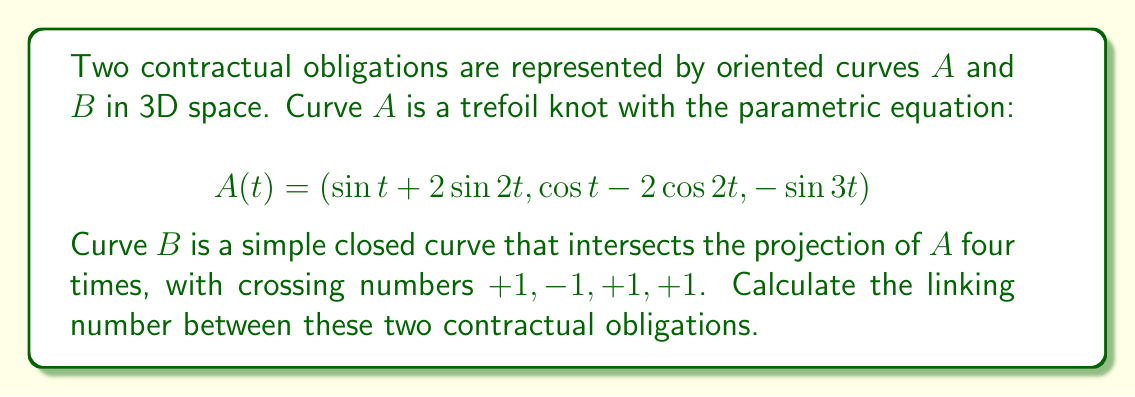Solve this math problem. To calculate the linking number between two curves, we need to follow these steps:

1. Identify the crossings in the projection of the two curves.
2. Determine the sign of each crossing.
3. Sum up the crossing numbers and divide by 2.

Given information:
- Curve $A$ is a trefoil knot (although its specific equation is not necessary for this calculation).
- Curve $B$ intersects the projection of $A$ four times.
- The crossing numbers are given as $+1, -1, +1, +1$.

Step 1: Sum up the crossing numbers
$$\text{Sum} = (+1) + (-1) + (+1) + (+1) = 2$$

Step 2: Calculate the linking number
$$\text{Linking Number} = \frac{\text{Sum}}{2} = \frac{2}{2} = 1$$

The linking number is an integer that measures how many times each curve winds around the other. A positive linking number indicates that the curves are linked in a right-handed sense, while a negative linking number indicates a left-handed link.

In this case, the linking number of 1 suggests that the two contractual obligations are intertwined once in a right-handed manner.
Answer: $1$ 